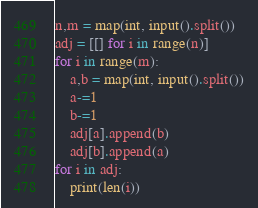Convert code to text. <code><loc_0><loc_0><loc_500><loc_500><_Python_>n,m = map(int, input().split())
adj = [[] for i in range(n)]
for i in range(m):
    a,b = map(int, input().split())
    a-=1
    b-=1
    adj[a].append(b)
    adj[b].append(a)
for i in adj:
    print(len(i))</code> 